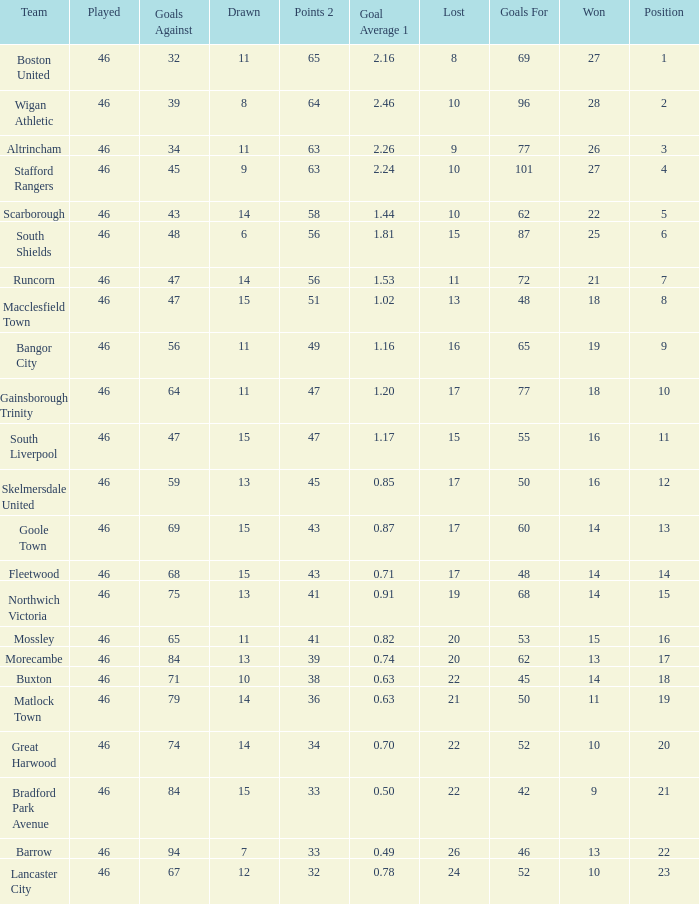How many points did Goole Town accumulate? 1.0. 